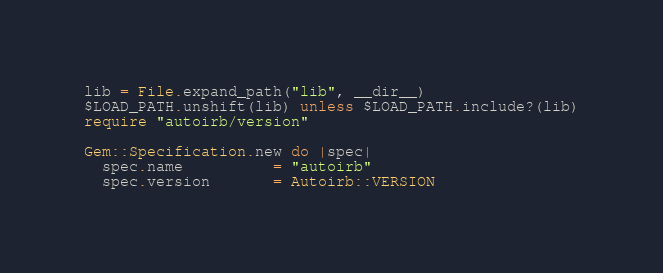<code> <loc_0><loc_0><loc_500><loc_500><_Ruby_>lib = File.expand_path("lib", __dir__)
$LOAD_PATH.unshift(lib) unless $LOAD_PATH.include?(lib)
require "autoirb/version"

Gem::Specification.new do |spec|
  spec.name          = "autoirb"
  spec.version       = Autoirb::VERSION</code> 